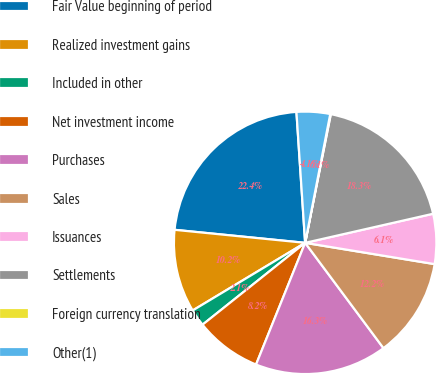<chart> <loc_0><loc_0><loc_500><loc_500><pie_chart><fcel>Fair Value beginning of period<fcel>Realized investment gains<fcel>Included in other<fcel>Net investment income<fcel>Purchases<fcel>Sales<fcel>Issuances<fcel>Settlements<fcel>Foreign currency translation<fcel>Other(1)<nl><fcel>22.36%<fcel>10.2%<fcel>2.1%<fcel>8.18%<fcel>16.28%<fcel>12.23%<fcel>6.15%<fcel>18.31%<fcel>0.07%<fcel>4.12%<nl></chart> 